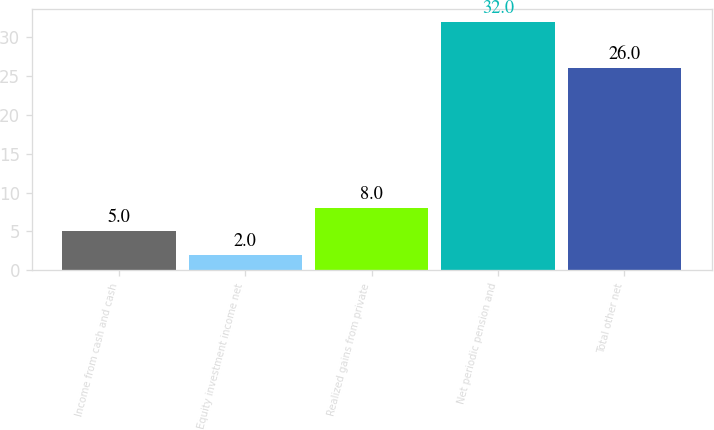Convert chart to OTSL. <chart><loc_0><loc_0><loc_500><loc_500><bar_chart><fcel>Income from cash and cash<fcel>Equity investment income net<fcel>Realized gains from private<fcel>Net periodic pension and<fcel>Total other net<nl><fcel>5<fcel>2<fcel>8<fcel>32<fcel>26<nl></chart> 